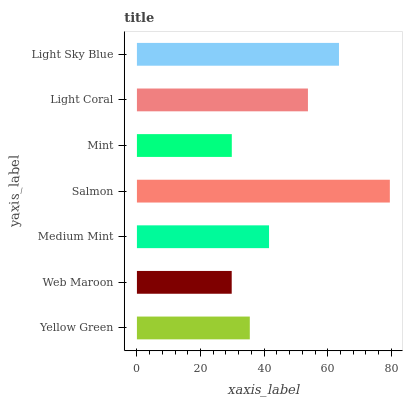Is Web Maroon the minimum?
Answer yes or no. Yes. Is Salmon the maximum?
Answer yes or no. Yes. Is Medium Mint the minimum?
Answer yes or no. No. Is Medium Mint the maximum?
Answer yes or no. No. Is Medium Mint greater than Web Maroon?
Answer yes or no. Yes. Is Web Maroon less than Medium Mint?
Answer yes or no. Yes. Is Web Maroon greater than Medium Mint?
Answer yes or no. No. Is Medium Mint less than Web Maroon?
Answer yes or no. No. Is Medium Mint the high median?
Answer yes or no. Yes. Is Medium Mint the low median?
Answer yes or no. Yes. Is Yellow Green the high median?
Answer yes or no. No. Is Light Coral the low median?
Answer yes or no. No. 